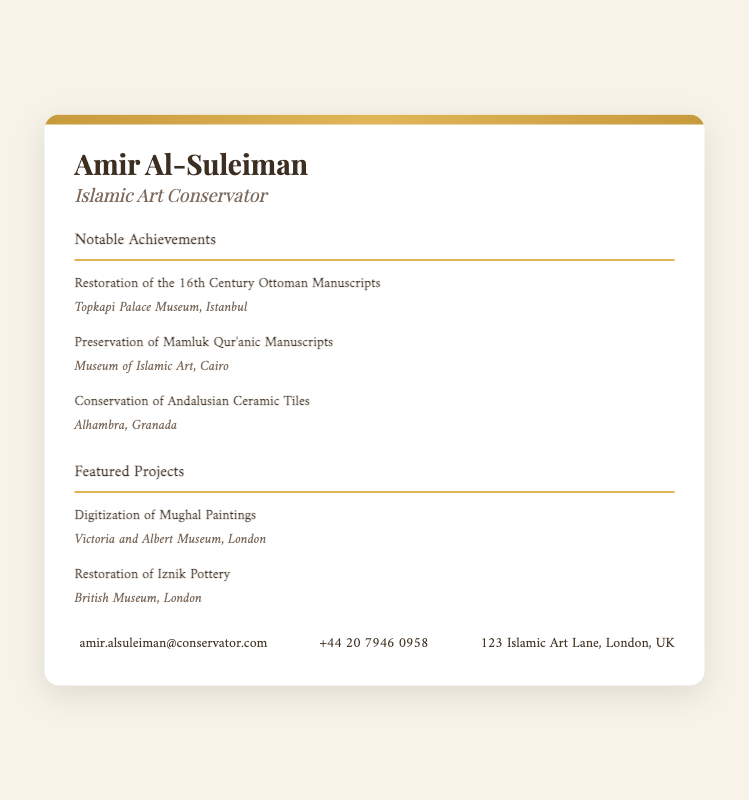what is the name of the conservator? The document states the name of the conservator at the top of the business card, which is Amir Al-Suleiman.
Answer: Amir Al-Suleiman what is the email address listed on the business card? The document provides contact information, including an email address in the contact section.
Answer: amir.alsuleiman@conservator.com how many notable achievements are listed? The document includes a section titled "Notable Achievements" where it lists specific achievements.
Answer: 3 where was the restoration of the 16th Century Ottoman Manuscripts conducted? The location is given in the notable achievements section next to the corresponding achievement.
Answer: Topkapi Palace Museum, Istanbul which featured project involves the British Museum? The document indicates featured projects and specifies the institution associated with each.
Answer: Restoration of Iznik Pottery what is the phone number provided? The phone number is part of the contact details section within the document.
Answer: +44 20 7946 0958 which project is related to the Victoria and Albert Museum? The document lists several featured projects and indicates the related museum.
Answer: Digitization of Mughal Paintings what type of card is this document? The structure and context of the document suggest its purpose within professional representation.
Answer: Business card 